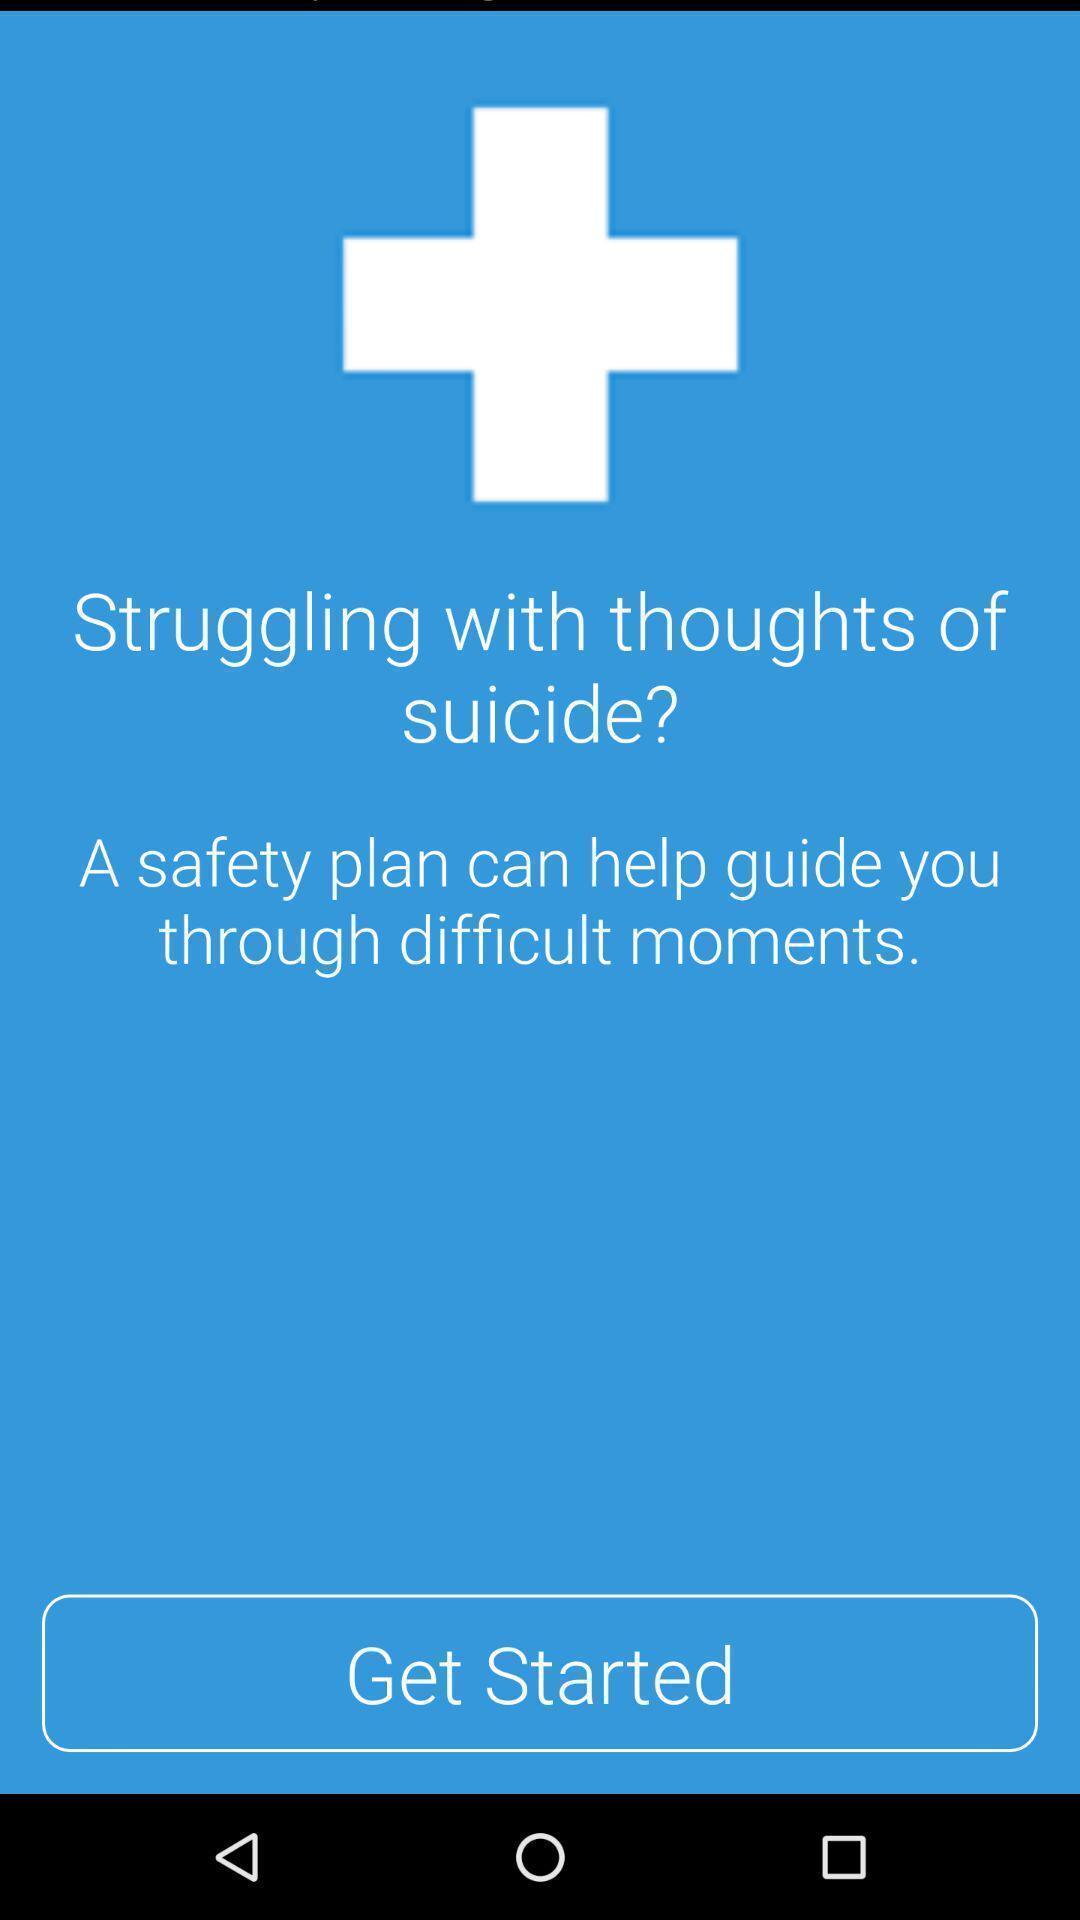What details can you identify in this image? Welcome page of a therapy app. 